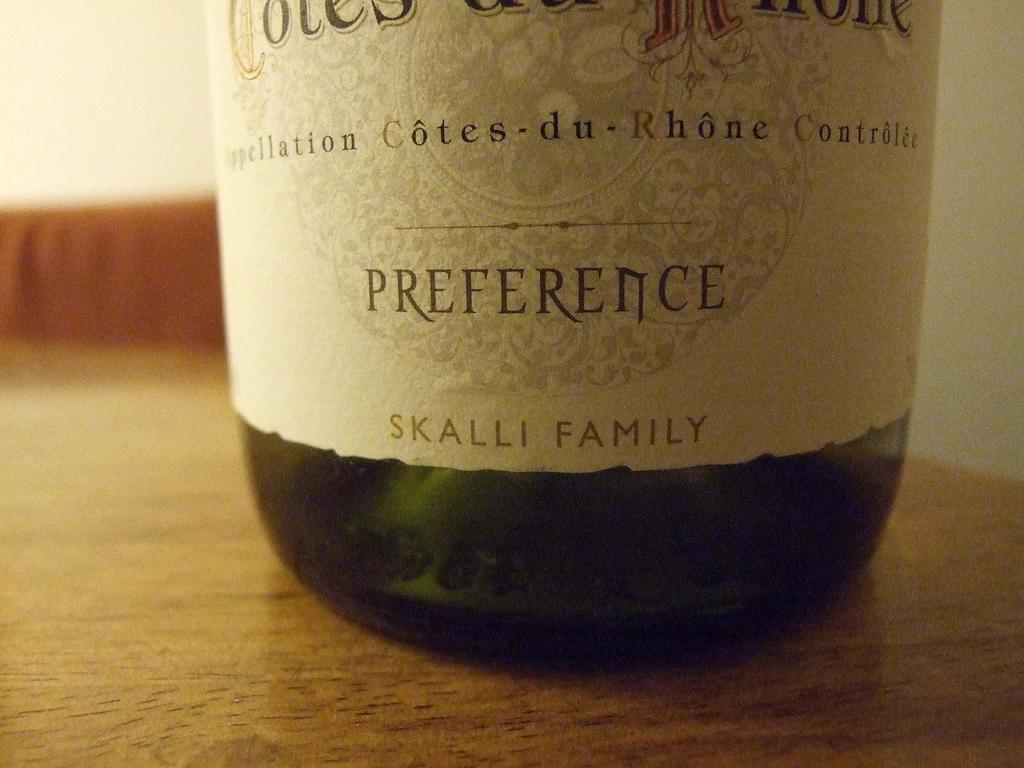<image>
Render a clear and concise summary of the photo. The bottom of a wine bottle label from France saying Preference and Skalli family. 